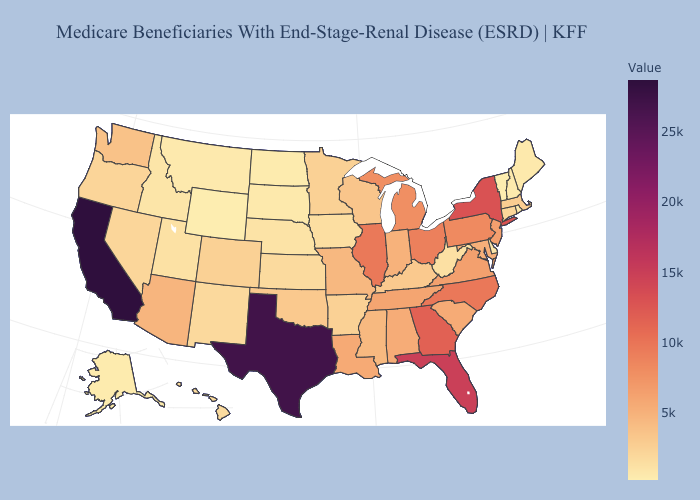Does Nevada have a lower value than Alabama?
Quick response, please. Yes. Does Pennsylvania have the lowest value in the Northeast?
Quick response, please. No. Among the states that border Wisconsin , does Iowa have the highest value?
Short answer required. No. Which states have the lowest value in the USA?
Answer briefly. Vermont. Which states have the lowest value in the South?
Answer briefly. Delaware. 